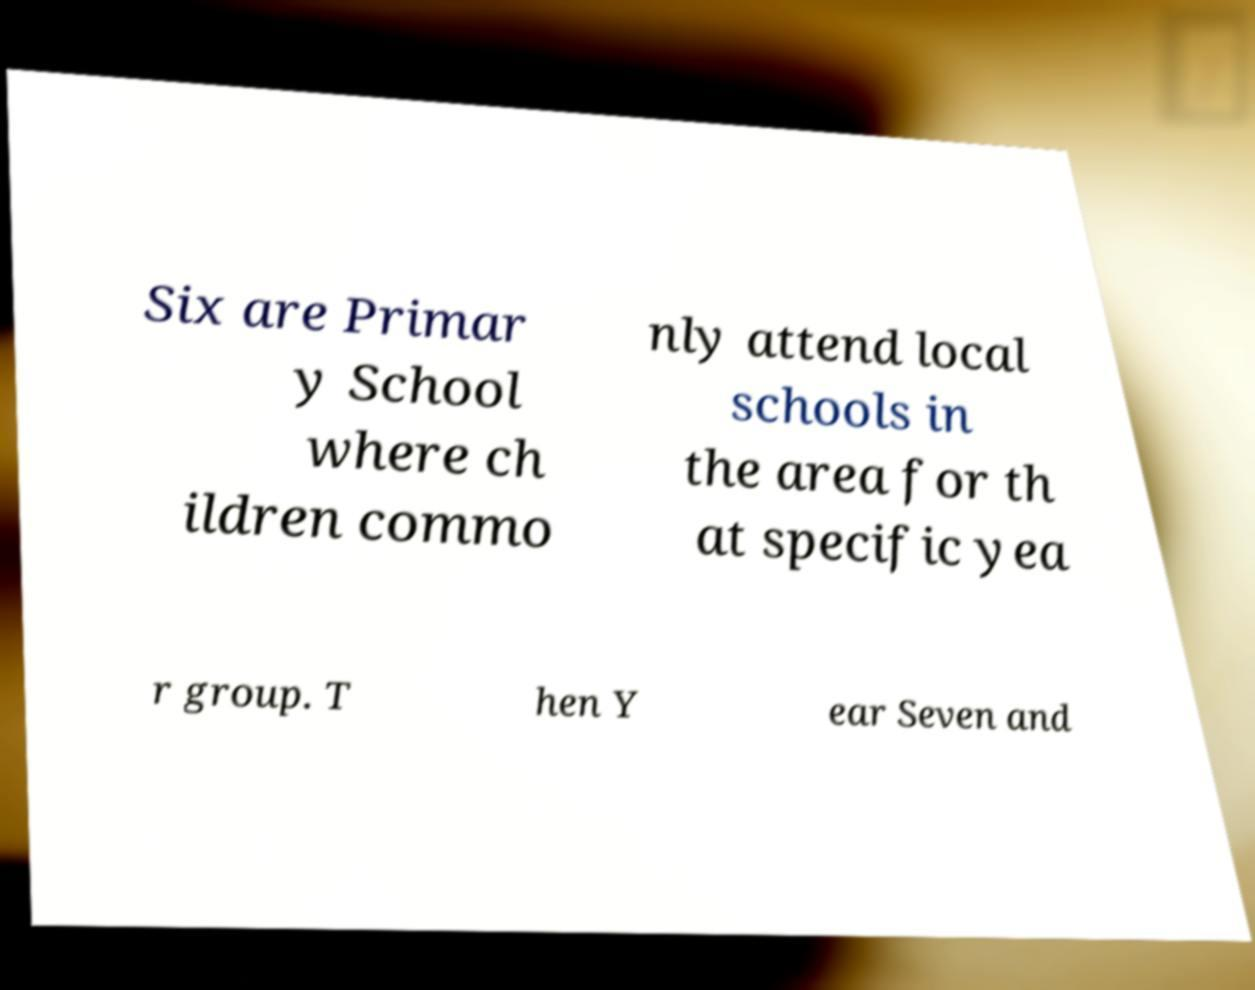Please identify and transcribe the text found in this image. Six are Primar y School where ch ildren commo nly attend local schools in the area for th at specific yea r group. T hen Y ear Seven and 